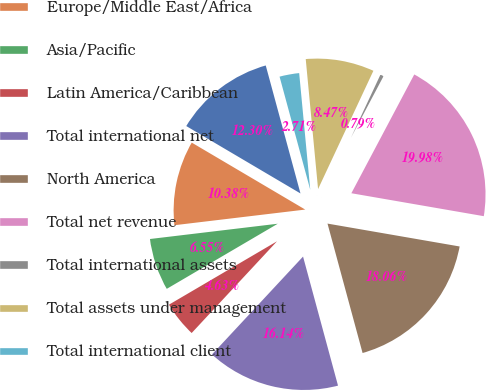<chart> <loc_0><loc_0><loc_500><loc_500><pie_chart><fcel>Year ended December 31 (in<fcel>Europe/Middle East/Africa<fcel>Asia/Pacific<fcel>Latin America/Caribbean<fcel>Total international net<fcel>North America<fcel>Total net revenue<fcel>Total international assets<fcel>Total assets under management<fcel>Total international client<nl><fcel>12.3%<fcel>10.38%<fcel>6.55%<fcel>4.63%<fcel>16.14%<fcel>18.06%<fcel>19.98%<fcel>0.79%<fcel>8.47%<fcel>2.71%<nl></chart> 